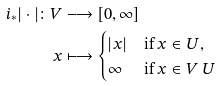<formula> <loc_0><loc_0><loc_500><loc_500>i _ { * } | \cdot | \colon V & \longrightarrow [ 0 , \infty ] \\ x & \longmapsto \begin{cases} | x | & \text {if $x \in U$} , \\ \infty & \text {if $x \in V \ U$} \end{cases}</formula> 